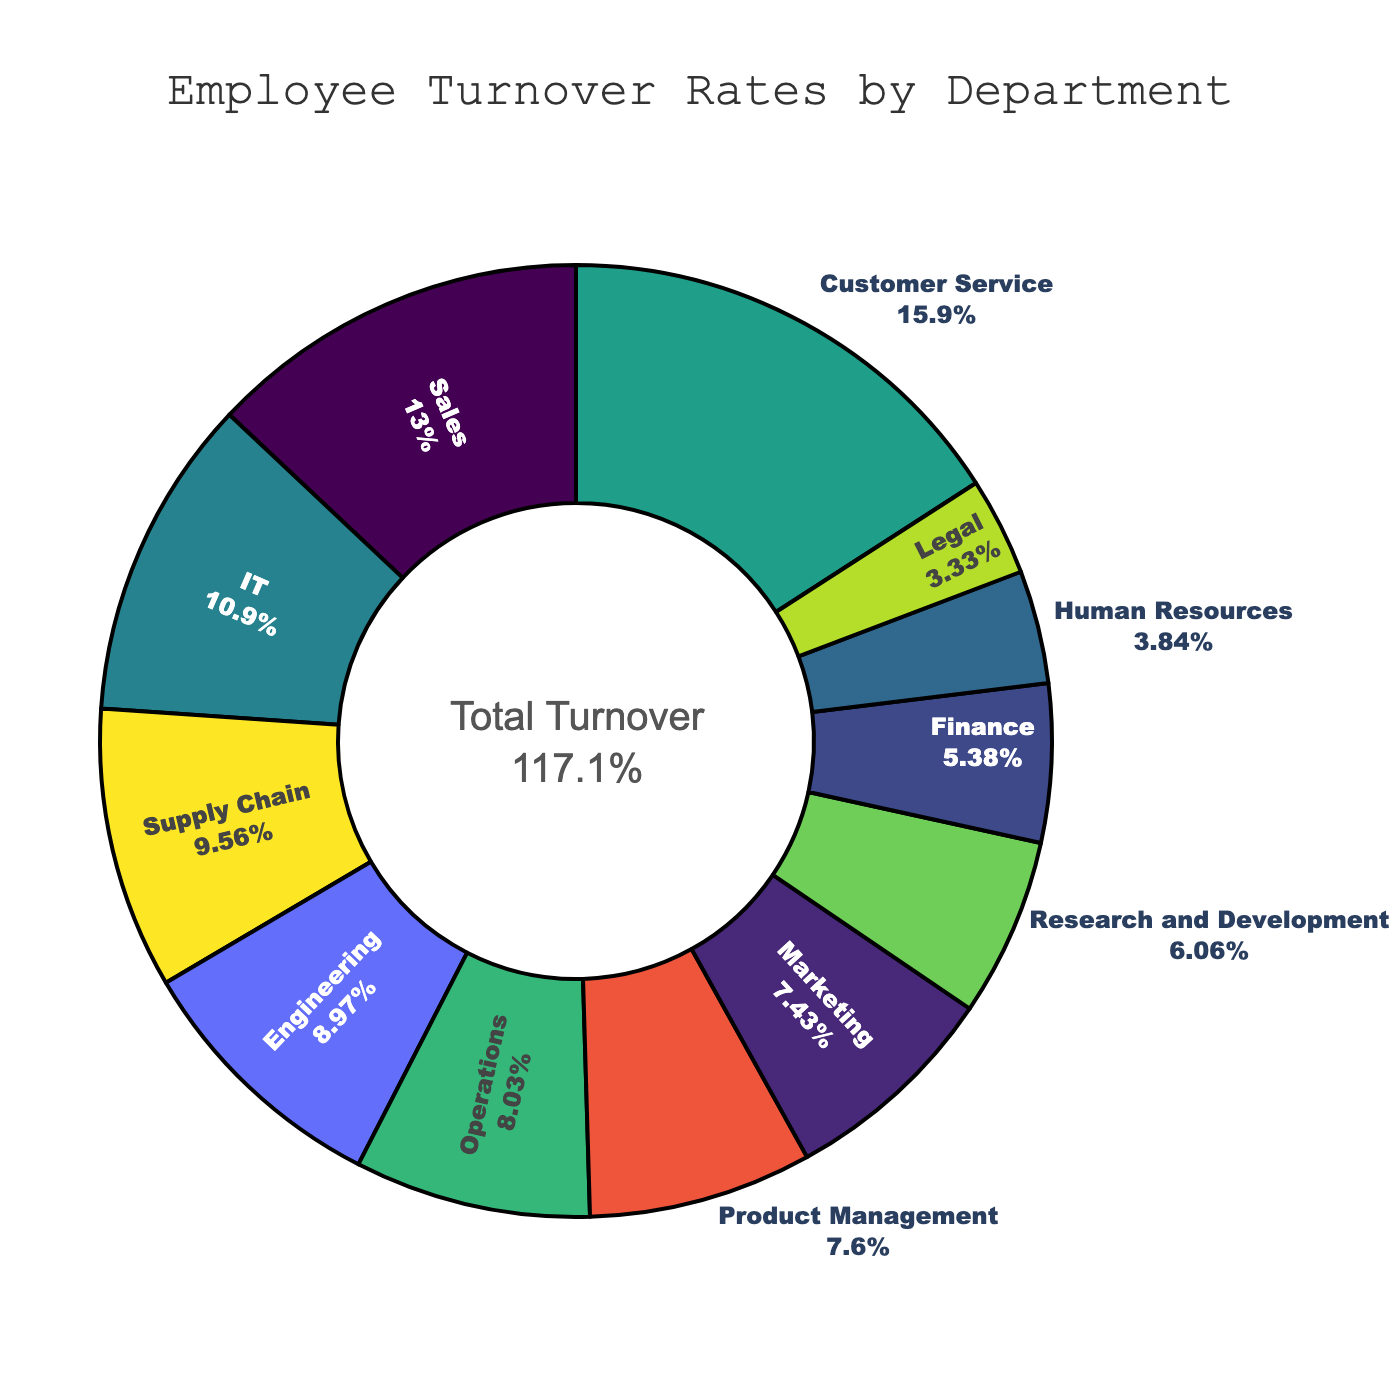What is the turnover rate for the Sales department? The turnover rate for the Sales department is directly labeled in the pie chart. Look for the Sales sector and read the percentage indicated.
Answer: 15.2% Which department has the lowest turnover rate? Identify the sector with the smallest size or read the labeled percentages to find the minimum value. The department with 3.9% turnover rate is the smallest sector.
Answer: Legal How does the turnover rate in IT compare to Finance? Locate the turnover rates for both IT and Finance in the pie chart. IT has a turnover rate of 12.8%, and Finance has a turnover rate of 6.3%. Compare these two values.
Answer: IT has a higher turnover rate than Finance What is the total turnover rate for all departments combined? The total turnover rate is displayed in the center of the pie chart.
Answer: 116.1% What percentage of the total turnover does Customer Service contribute? Find the turnover rate for Customer Service and calculate its percentage of the total turnover. The total turnover is 116.1%, and Customer Service's rate is 18.6%. The percentage contribution is (18.6 / 116.1) * 100.
Answer: 16.0% Compare the turnover rates between Marketing and Research and Development. Which one is higher and by how much? Locate the turnover rates for Marketing (8.7%) and Research and Development (7.1%). Subtract the smaller value from the larger one.
Answer: Marketing has a higher turnover rate by 1.6% Which departments have a turnover rate higher than 10%? Scan the pie chart and read the labels to identify departments with turnover rates above 10%.
Answer: Sales, IT, Customer Service, Supply Chain, Engineering What is the average turnover rate for the Legal, Human Resources, and Finance departments? Add the turnover rates for these departments: Legal (3.9%), Human Resources (4.5%), and Finance (6.3%). Divide the sum by the number of departments (3).
Answer: 4.9% Sum the turnover rates of the Customer Service, Sales, and IT departments. Identify the turnover rates for these departments (Customer Service: 18.6%, Sales: 15.2%, IT: 12.8%) and add them together.
Answer: 46.6% What are the turnover rates for departments with a rate less than 5%? Locate the sectors in the pie chart with turnover rates less than 5%.
Answer: Human Resources: 4.5%, Legal: 3.9% 